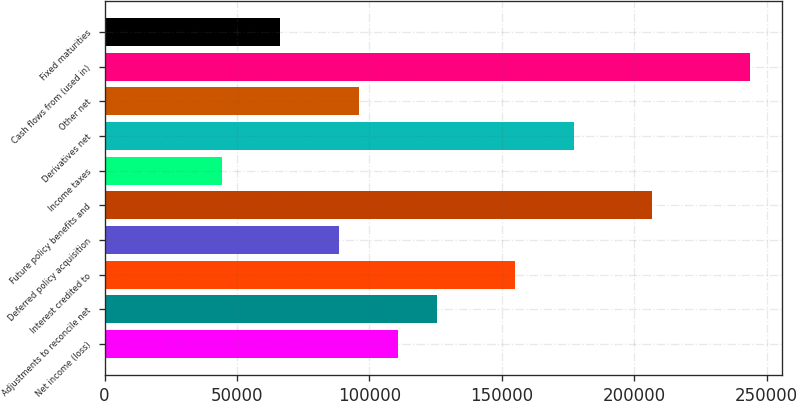Convert chart to OTSL. <chart><loc_0><loc_0><loc_500><loc_500><bar_chart><fcel>Net income (loss)<fcel>Adjustments to reconcile net<fcel>Interest credited to<fcel>Deferred policy acquisition<fcel>Future policy benefits and<fcel>Income taxes<fcel>Derivatives net<fcel>Other net<fcel>Cash flows from (used in)<fcel>Fixed maturities<nl><fcel>110734<fcel>125499<fcel>155027<fcel>88587.4<fcel>206703<fcel>44294<fcel>177174<fcel>95969.6<fcel>243614<fcel>66440.7<nl></chart> 